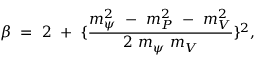<formula> <loc_0><loc_0><loc_500><loc_500>\beta = 2 + \{ \frac { m _ { \psi } ^ { 2 } - m _ { P } ^ { 2 } - m _ { V } ^ { 2 } } { 2 m _ { \psi } m _ { V } } \} ^ { 2 } ,</formula> 